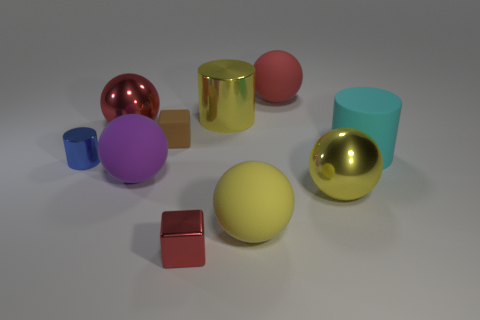Do the small block in front of the small matte object and the big yellow cylinder have the same material?
Offer a terse response. Yes. The large red metallic thing has what shape?
Your answer should be very brief. Sphere. What number of red things are either small metal cylinders or large rubber balls?
Offer a very short reply. 1. What number of other objects are the same material as the small blue cylinder?
Give a very brief answer. 4. Does the tiny object in front of the tiny metallic cylinder have the same shape as the big cyan rubber object?
Your answer should be compact. No. Is there a green metallic cube?
Provide a succinct answer. No. Is there any other thing that is the same shape as the brown rubber thing?
Your response must be concise. Yes. Are there more large spheres right of the big yellow metallic cylinder than big yellow cylinders?
Provide a short and direct response. Yes. There is a tiny blue cylinder; are there any brown things left of it?
Your response must be concise. No. Does the yellow shiny sphere have the same size as the cyan thing?
Provide a short and direct response. Yes. 